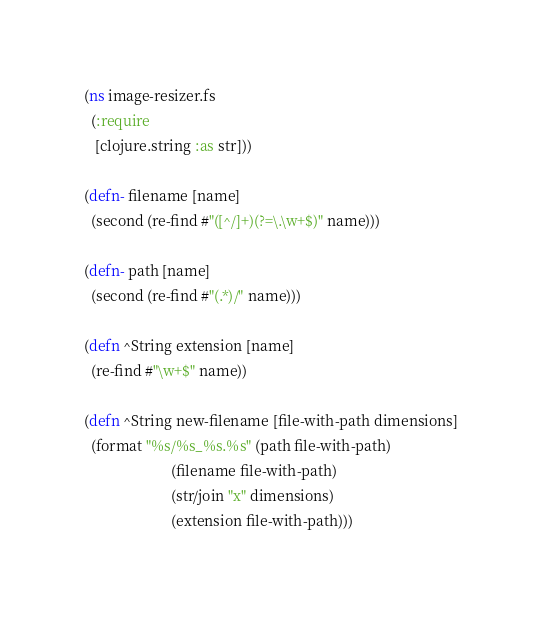<code> <loc_0><loc_0><loc_500><loc_500><_Clojure_>(ns image-resizer.fs
  (:require
   [clojure.string :as str]))

(defn- filename [name]
  (second (re-find #"([^/]+)(?=\.\w+$)" name)))

(defn- path [name]
  (second (re-find #"(.*)/" name)))

(defn ^String extension [name]
  (re-find #"\w+$" name))

(defn ^String new-filename [file-with-path dimensions]
  (format "%s/%s_%s.%s" (path file-with-path)
                        (filename file-with-path)
                        (str/join "x" dimensions)
                        (extension file-with-path)))
</code> 